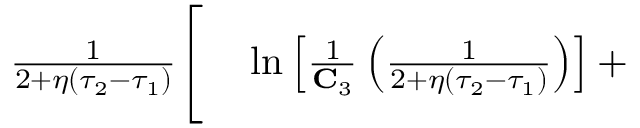<formula> <loc_0><loc_0><loc_500><loc_500>\begin{array} { r l } { \frac { 1 } { 2 + \eta ( \tau _ { 2 } - \tau _ { 1 } ) } \Big [ } & \ln \left [ \frac { 1 } { C _ { 3 } } \left ( \frac { 1 } { 2 + \eta ( \tau _ { 2 } - \tau _ { 1 } ) } \right ) \right ] + } \end{array}</formula> 